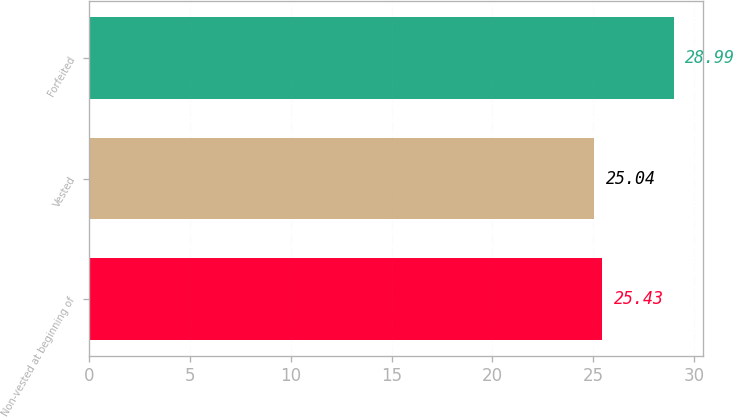<chart> <loc_0><loc_0><loc_500><loc_500><bar_chart><fcel>Non-vested at beginning of<fcel>Vested<fcel>Forfeited<nl><fcel>25.43<fcel>25.04<fcel>28.99<nl></chart> 